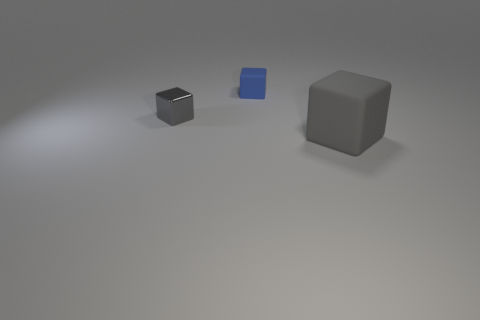Are there any other things that are the same size as the gray rubber block?
Your response must be concise. No. Is there a matte sphere of the same color as the tiny rubber block?
Provide a succinct answer. No. Do the big object and the small thing that is behind the gray metallic thing have the same material?
Ensure brevity in your answer.  Yes. What number of small things are gray blocks or cyan shiny cylinders?
Provide a succinct answer. 1. There is a large block that is the same color as the small shiny cube; what is its material?
Offer a terse response. Rubber. Is the number of green rubber things less than the number of large gray rubber cubes?
Provide a succinct answer. Yes. Do the matte cube behind the gray rubber cube and the gray cube that is behind the big gray object have the same size?
Ensure brevity in your answer.  Yes. What number of red objects are either tiny rubber objects or big objects?
Give a very brief answer. 0. There is another metallic object that is the same color as the big object; what is its size?
Give a very brief answer. Small. Are there more big blue rubber cylinders than blue rubber cubes?
Your response must be concise. No. 